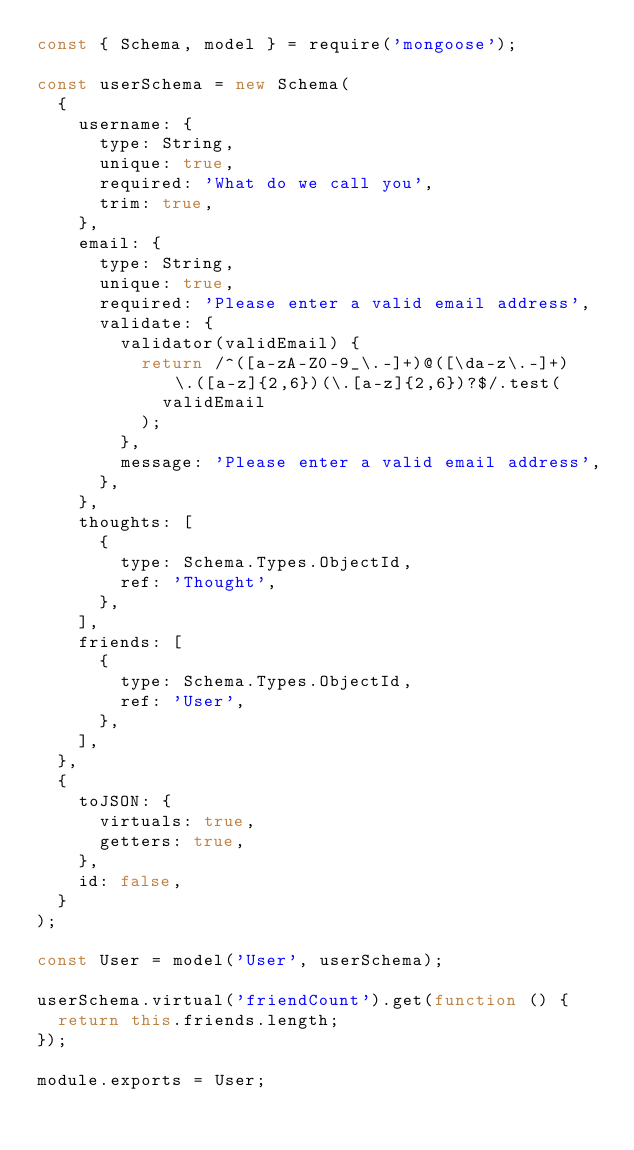<code> <loc_0><loc_0><loc_500><loc_500><_JavaScript_>const { Schema, model } = require('mongoose');

const userSchema = new Schema(
  {
    username: {
      type: String,
      unique: true,
      required: 'What do we call you',
      trim: true,
    },
    email: {
      type: String,
      unique: true,
      required: 'Please enter a valid email address',
      validate: {
        validator(validEmail) {
          return /^([a-zA-Z0-9_\.-]+)@([\da-z\.-]+)\.([a-z]{2,6})(\.[a-z]{2,6})?$/.test(
            validEmail
          );
        },
        message: 'Please enter a valid email address',
      },
    },
    thoughts: [
      {
        type: Schema.Types.ObjectId,
        ref: 'Thought',
      },
    ],
    friends: [
      {
        type: Schema.Types.ObjectId,
        ref: 'User',
      },
    ],
  },
  {
    toJSON: {
      virtuals: true,
      getters: true,
    },
    id: false,
  }
);

const User = model('User', userSchema);

userSchema.virtual('friendCount').get(function () {
  return this.friends.length;
});

module.exports = User;
</code> 